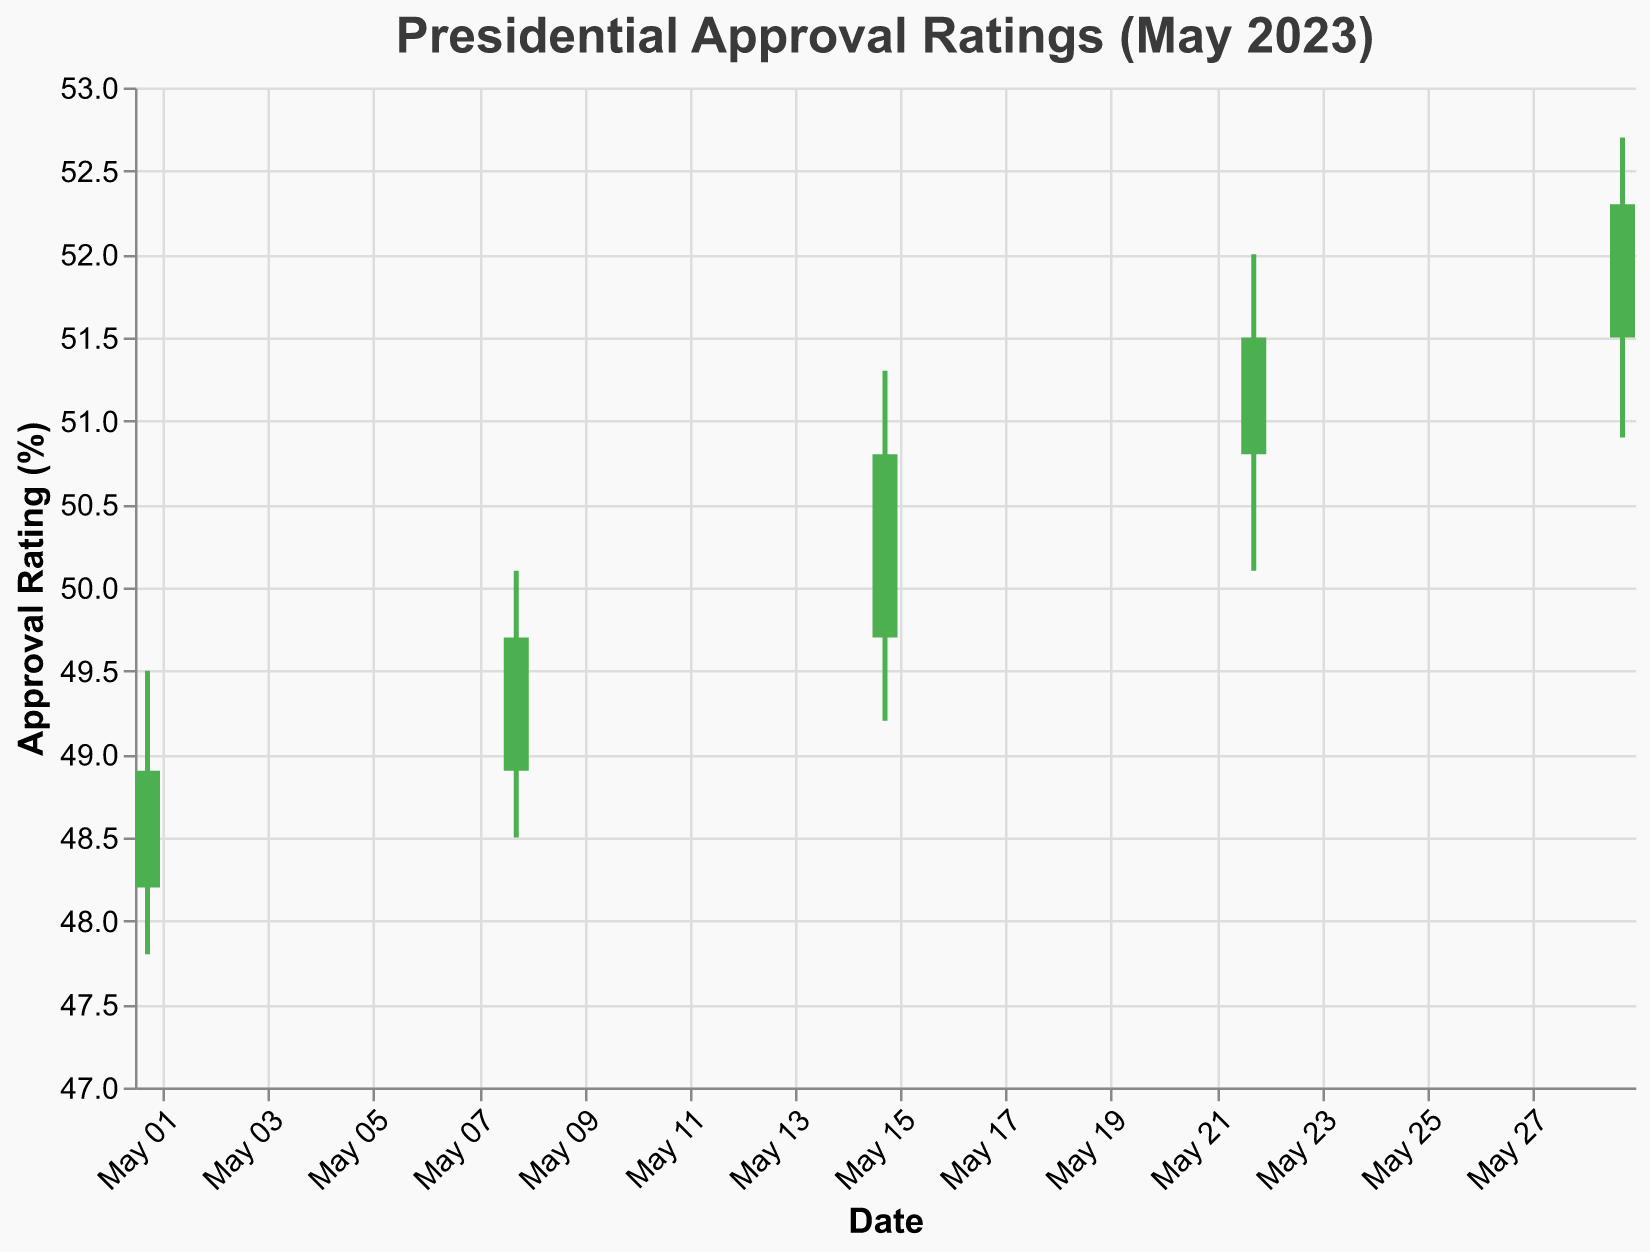What is the highest approval rating recorded in May 2023? To find the highest approval rating, check the "High" values across all dates and identify the maximum. The highest value is 52.7 on May 29.
Answer: 52.7 What trend can be observed in the approval ratings over the month? To observe the trend, check the "Close" values from May 1 to May 29. The values increase progressively from 48.9 on May 1 to 52.3 on May 29, indicating an upward trend.
Answer: Upward trend What was the approval rating at the open and close on May 15? For May 15, refer to the "Open" and "Close" columns. The values are 49.7 and 50.8, respectively.
Answer: 49.7, 50.8 Which day had the lowest opening approval rating? Compare the "Open" values on all dates. The lowest value is 48.2 on May 1.
Answer: May 1 By how much did the approval rating increase from the open to the close on May 22? To find the increase, subtract the "Open" value from the "Close" value on May 22. The values are 51.5 - 50.8.
Answer: 0.7 On which date did the approval rating fluctuate the most, and what was the range? To find the fluctuation range, calculate the difference between "High" and "Low" values for each date. The largest fluctuation is from 52.7 to 50.9 on May 29, with a range of 1.8.
Answer: May 29, 1.8 Was there any week where the approval rating decreased from the open to the close? Check the "Open" and "Close" values for all dates. Each "Close" value is higher than its respective "Open" value, indicating no decrease occurred.
Answer: No What is the average closing approval rating for May 2023? Sum all "Close" values and divide by the number of data points. The sum is 48.9 + 49.7 + 50.8 + 51.5 + 52.3 = 253.2. There are 5 data points, so 253.2 / 5 = 50.64.
Answer: 50.64 Which date shows the smallest upward movement in approval rating from open to close? Calculate the difference between "Close" and "Open" values for each date. The smallest positive difference is on May 1, with a difference of 48.9 - 48.2 = 0.7.
Answer: May 1 